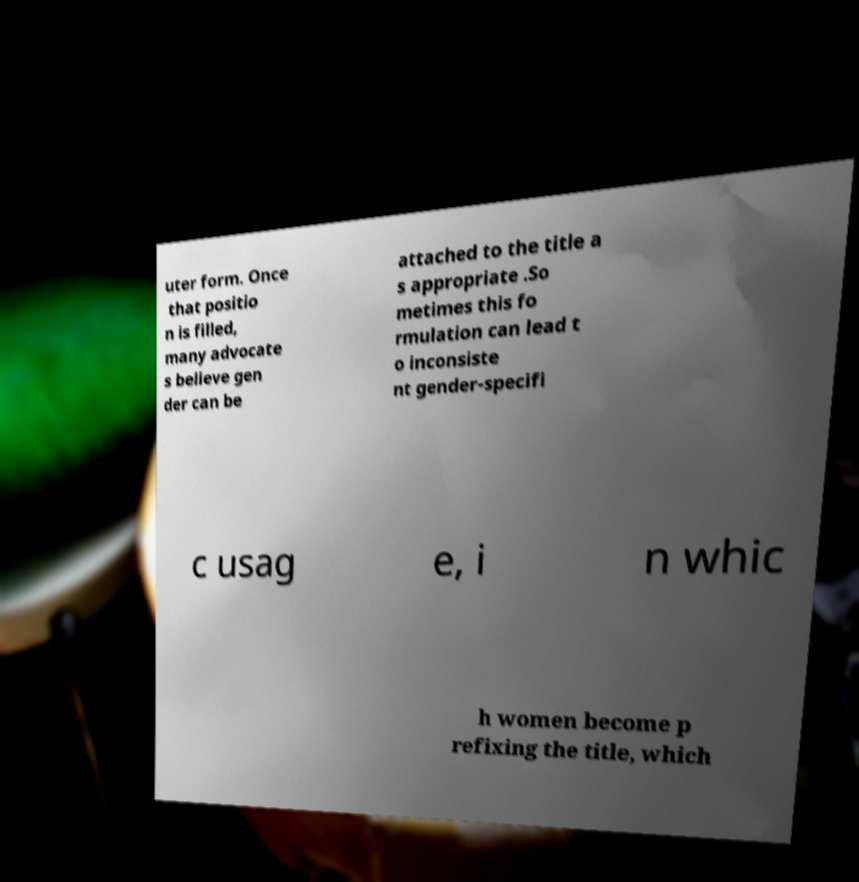There's text embedded in this image that I need extracted. Can you transcribe it verbatim? uter form. Once that positio n is filled, many advocate s believe gen der can be attached to the title a s appropriate .So metimes this fo rmulation can lead t o inconsiste nt gender-specifi c usag e, i n whic h women become p refixing the title, which 